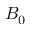Convert formula to latex. <formula><loc_0><loc_0><loc_500><loc_500>B _ { 0 }</formula> 